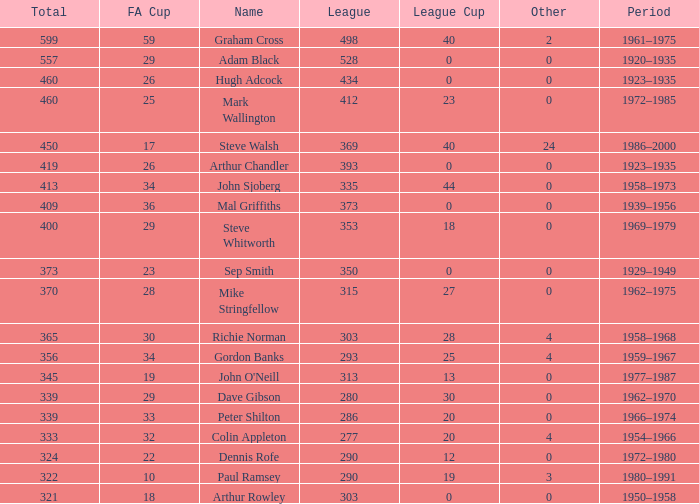What is the lowest number of League Cups a player with a 434 league has? 0.0. 